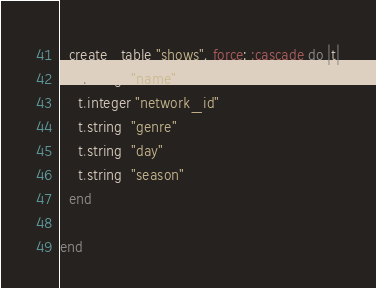Convert code to text. <code><loc_0><loc_0><loc_500><loc_500><_Ruby_>  create_table "shows", force: :cascade do |t|
    t.string  "name"
    t.integer "network_id"
    t.string  "genre"
    t.string  "day"
    t.string  "season"
  end

end
</code> 